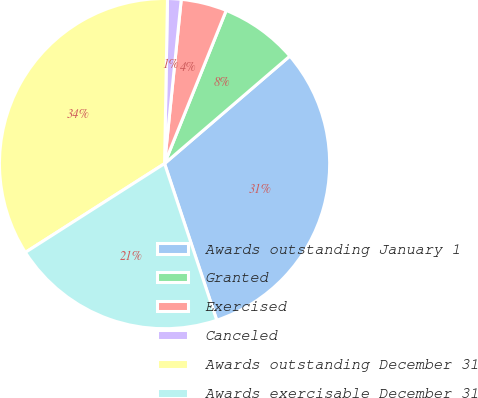<chart> <loc_0><loc_0><loc_500><loc_500><pie_chart><fcel>Awards outstanding January 1<fcel>Granted<fcel>Exercised<fcel>Canceled<fcel>Awards outstanding December 31<fcel>Awards exercisable December 31<nl><fcel>31.17%<fcel>7.62%<fcel>4.48%<fcel>1.33%<fcel>34.32%<fcel>21.08%<nl></chart> 